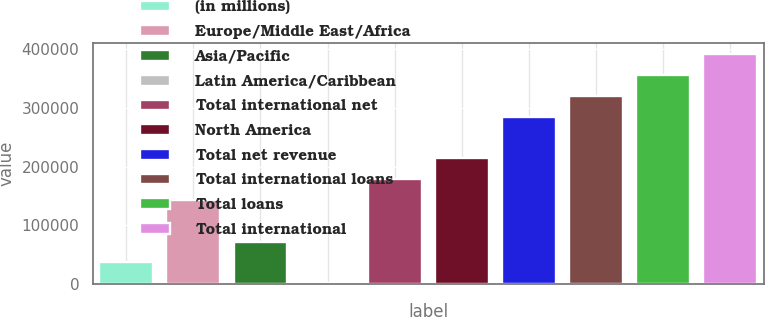Convert chart to OTSL. <chart><loc_0><loc_0><loc_500><loc_500><bar_chart><fcel>(in millions)<fcel>Europe/Middle East/Africa<fcel>Asia/Pacific<fcel>Latin America/Caribbean<fcel>Total international net<fcel>North America<fcel>Total net revenue<fcel>Total international loans<fcel>Total loans<fcel>Total international<nl><fcel>36956.3<fcel>143226<fcel>72379.6<fcel>1533<fcel>178650<fcel>214073<fcel>284919<fcel>320343<fcel>355766<fcel>391189<nl></chart> 